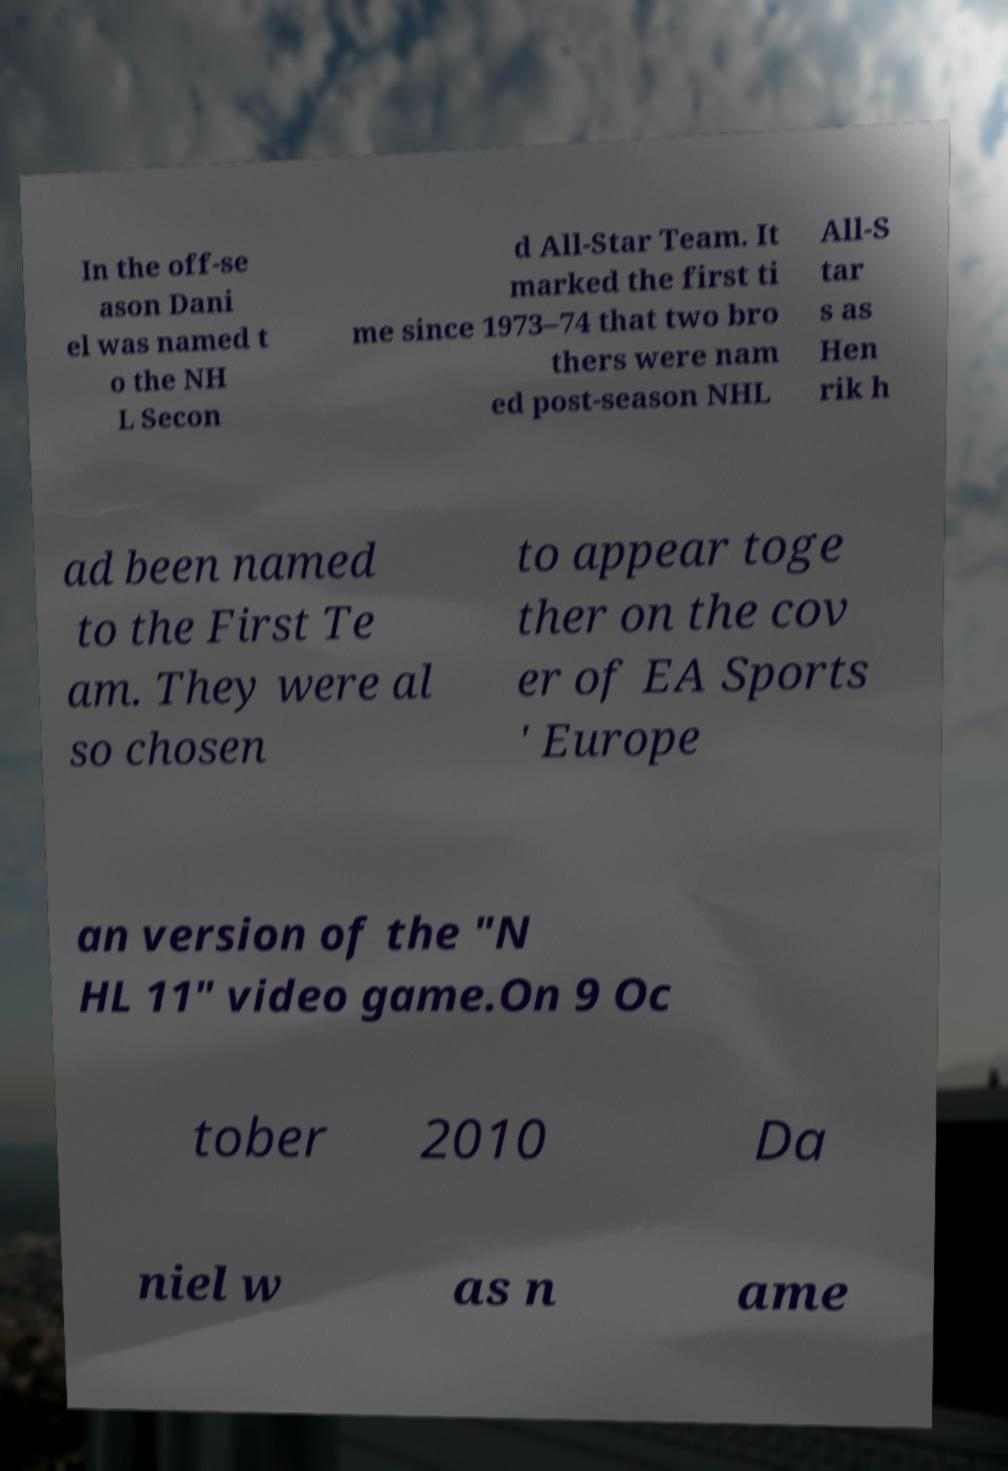Can you accurately transcribe the text from the provided image for me? In the off-se ason Dani el was named t o the NH L Secon d All-Star Team. It marked the first ti me since 1973–74 that two bro thers were nam ed post-season NHL All-S tar s as Hen rik h ad been named to the First Te am. They were al so chosen to appear toge ther on the cov er of EA Sports ' Europe an version of the "N HL 11" video game.On 9 Oc tober 2010 Da niel w as n ame 